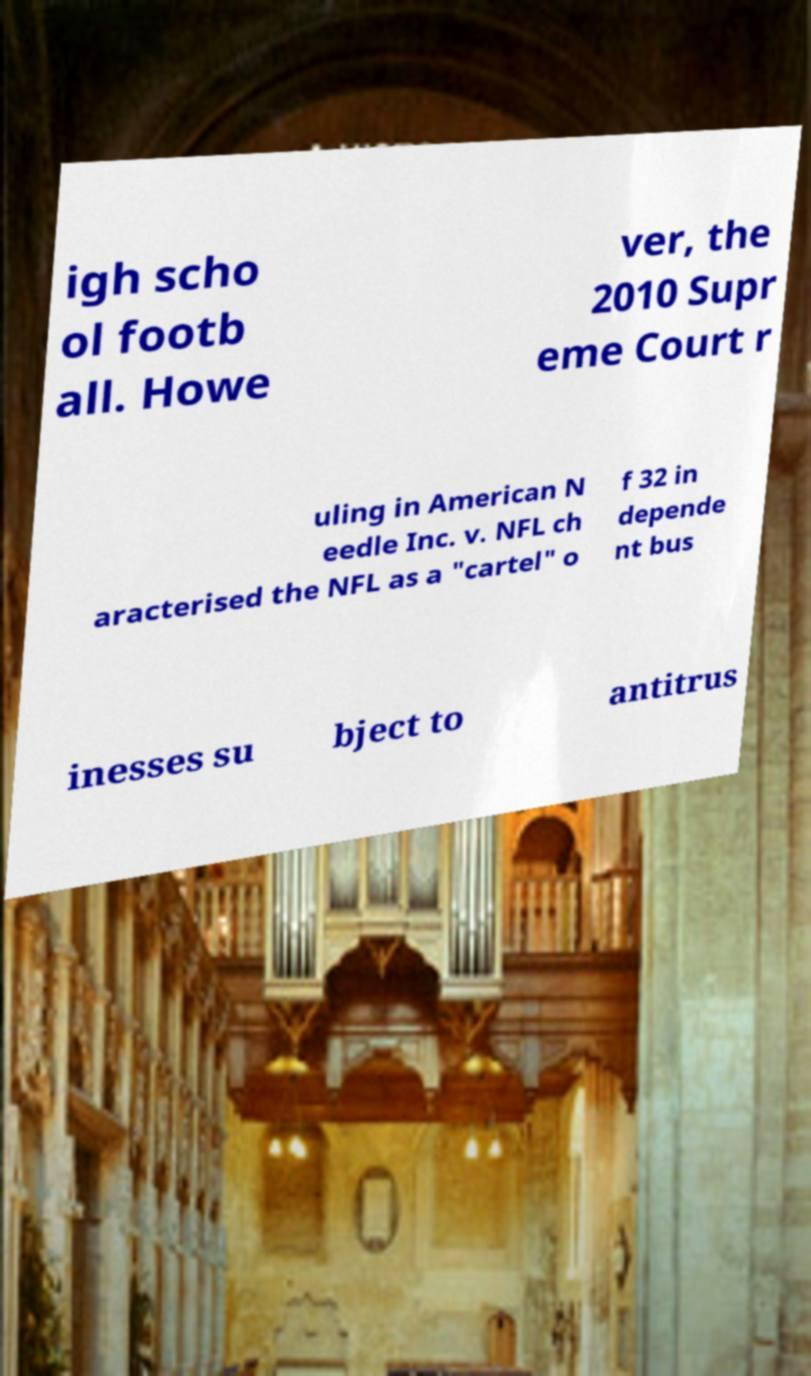Please read and relay the text visible in this image. What does it say? igh scho ol footb all. Howe ver, the 2010 Supr eme Court r uling in American N eedle Inc. v. NFL ch aracterised the NFL as a "cartel" o f 32 in depende nt bus inesses su bject to antitrus 